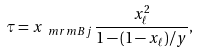Convert formula to latex. <formula><loc_0><loc_0><loc_500><loc_500>\tau = x _ { \ m r m { B j } } \, \frac { x _ { \ell } ^ { 2 } } { 1 - ( 1 - x _ { \ell } ) / y } ,</formula> 